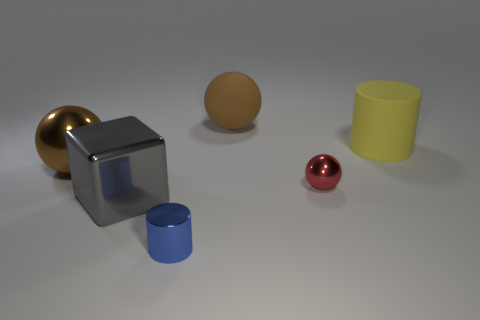There is another thing that is the same shape as the small blue shiny object; what size is it?
Make the answer very short. Large. Is there anything else that is the same size as the yellow rubber cylinder?
Your answer should be compact. Yes. How many other objects are the same color as the matte sphere?
Your answer should be very brief. 1. What number of cylinders are either tiny blue things or metallic things?
Make the answer very short. 1. There is a large thing on the right side of the shiny object right of the blue shiny cylinder; what is its color?
Your answer should be very brief. Yellow. What shape is the red thing?
Provide a short and direct response. Sphere. There is a metallic thing behind the red object; is its size the same as the large rubber sphere?
Ensure brevity in your answer.  Yes. Are there any red things that have the same material as the gray cube?
Your answer should be very brief. Yes. What number of things are either objects that are behind the blue thing or big yellow rubber objects?
Your answer should be compact. 5. Is there a large brown metal thing?
Your answer should be compact. Yes. 